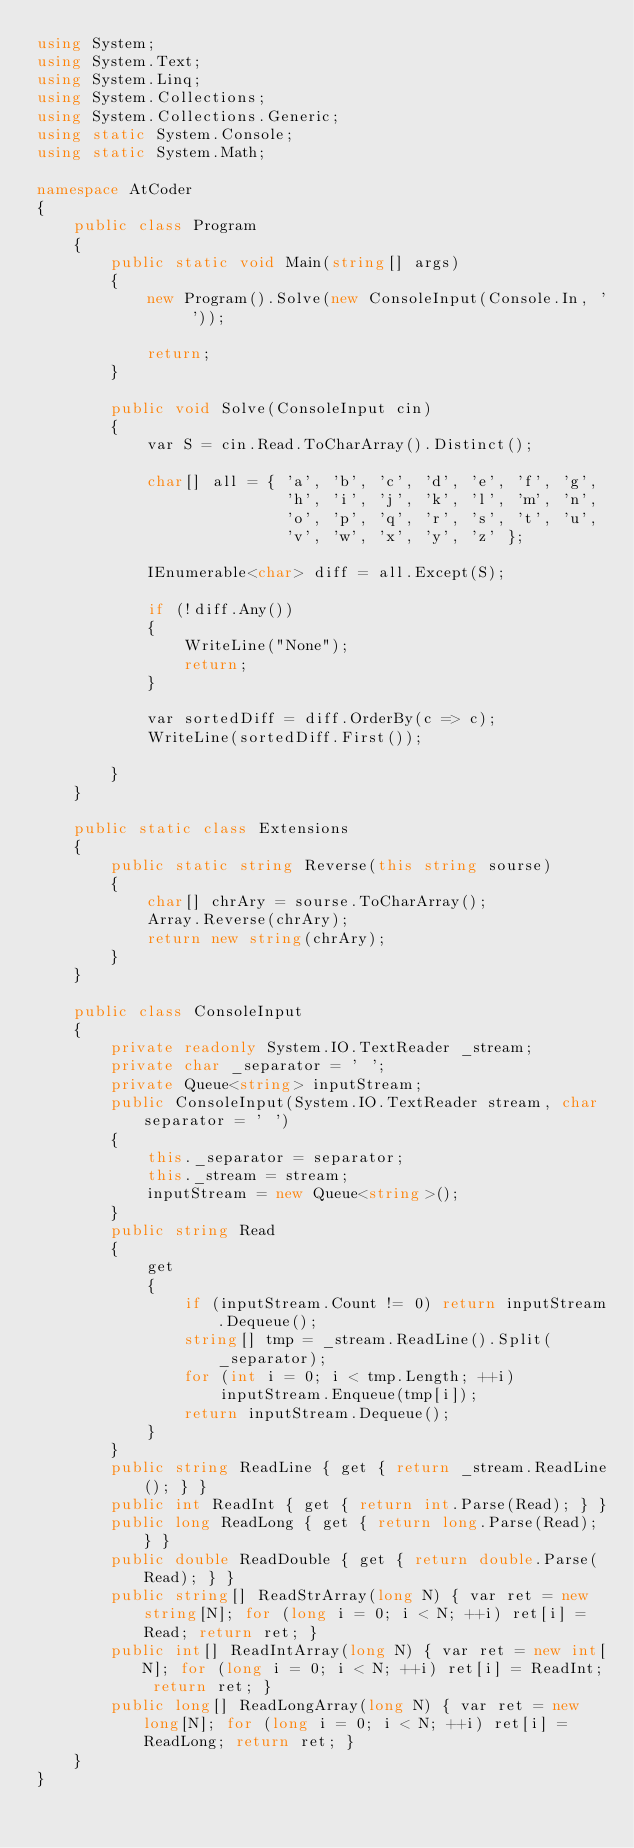<code> <loc_0><loc_0><loc_500><loc_500><_C#_>using System;
using System.Text;
using System.Linq;
using System.Collections;
using System.Collections.Generic;
using static System.Console;
using static System.Math;

namespace AtCoder
{
    public class Program
    {
        public static void Main(string[] args)
        {
            new Program().Solve(new ConsoleInput(Console.In, ' '));

            return;
        }

        public void Solve(ConsoleInput cin)
        {
            var S = cin.Read.ToCharArray().Distinct();

            char[] all = { 'a', 'b', 'c', 'd', 'e', 'f', 'g',
                           'h', 'i', 'j', 'k', 'l', 'm', 'n',
                           'o', 'p', 'q', 'r', 's', 't', 'u',
                           'v', 'w', 'x', 'y', 'z' };

            IEnumerable<char> diff = all.Except(S);

            if (!diff.Any())
            {
                WriteLine("None");
                return;
            }

            var sortedDiff = diff.OrderBy(c => c);
            WriteLine(sortedDiff.First());

        }
    }

    public static class Extensions
    {
        public static string Reverse(this string sourse)
        {
            char[] chrAry = sourse.ToCharArray();
            Array.Reverse(chrAry);
            return new string(chrAry);
        }
    }

    public class ConsoleInput
    {
        private readonly System.IO.TextReader _stream;
        private char _separator = ' ';
        private Queue<string> inputStream;
        public ConsoleInput(System.IO.TextReader stream, char separator = ' ')
        {
            this._separator = separator;
            this._stream = stream;
            inputStream = new Queue<string>();
        }
        public string Read
        {
            get
            {
                if (inputStream.Count != 0) return inputStream.Dequeue();
                string[] tmp = _stream.ReadLine().Split(_separator);
                for (int i = 0; i < tmp.Length; ++i)
                    inputStream.Enqueue(tmp[i]);
                return inputStream.Dequeue();
            }
        }
        public string ReadLine { get { return _stream.ReadLine(); } }
        public int ReadInt { get { return int.Parse(Read); } }
        public long ReadLong { get { return long.Parse(Read); } }
        public double ReadDouble { get { return double.Parse(Read); } }
        public string[] ReadStrArray(long N) { var ret = new string[N]; for (long i = 0; i < N; ++i) ret[i] = Read; return ret; }
        public int[] ReadIntArray(long N) { var ret = new int[N]; for (long i = 0; i < N; ++i) ret[i] = ReadInt; return ret; }
        public long[] ReadLongArray(long N) { var ret = new long[N]; for (long i = 0; i < N; ++i) ret[i] = ReadLong; return ret; }
    }
}</code> 